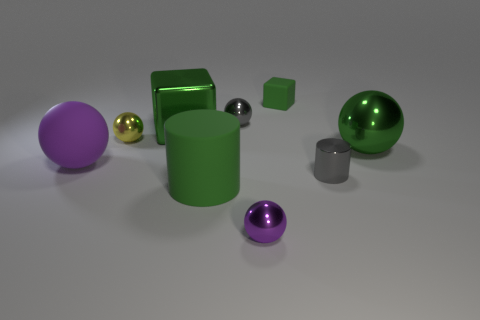Can you tell me what materials the objects in the image might be made of? The objects appear to be made of a variety of materials: the reflective, shiny spheres could be metallic or glass, the matte-textured cubes look plastic or rubber, and the cylindrical shapes have a metallic luster that suggests they could be made of either polished metal or a high-gloss plastic. 